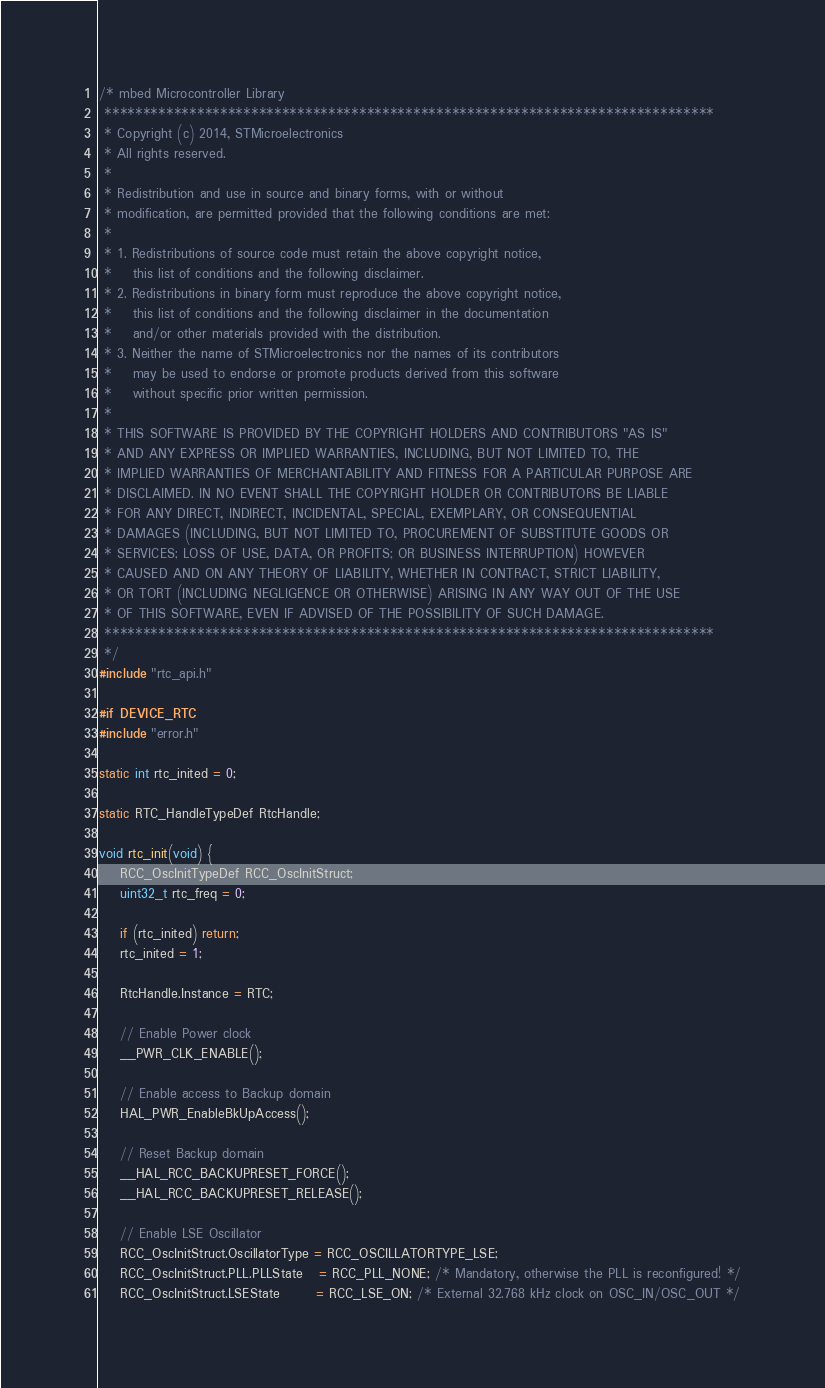<code> <loc_0><loc_0><loc_500><loc_500><_C_>/* mbed Microcontroller Library
 *******************************************************************************
 * Copyright (c) 2014, STMicroelectronics
 * All rights reserved.
 *
 * Redistribution and use in source and binary forms, with or without
 * modification, are permitted provided that the following conditions are met:
 *
 * 1. Redistributions of source code must retain the above copyright notice,
 *    this list of conditions and the following disclaimer.
 * 2. Redistributions in binary form must reproduce the above copyright notice,
 *    this list of conditions and the following disclaimer in the documentation
 *    and/or other materials provided with the distribution.
 * 3. Neither the name of STMicroelectronics nor the names of its contributors
 *    may be used to endorse or promote products derived from this software
 *    without specific prior written permission.
 *
 * THIS SOFTWARE IS PROVIDED BY THE COPYRIGHT HOLDERS AND CONTRIBUTORS "AS IS"
 * AND ANY EXPRESS OR IMPLIED WARRANTIES, INCLUDING, BUT NOT LIMITED TO, THE
 * IMPLIED WARRANTIES OF MERCHANTABILITY AND FITNESS FOR A PARTICULAR PURPOSE ARE
 * DISCLAIMED. IN NO EVENT SHALL THE COPYRIGHT HOLDER OR CONTRIBUTORS BE LIABLE
 * FOR ANY DIRECT, INDIRECT, INCIDENTAL, SPECIAL, EXEMPLARY, OR CONSEQUENTIAL
 * DAMAGES (INCLUDING, BUT NOT LIMITED TO, PROCUREMENT OF SUBSTITUTE GOODS OR
 * SERVICES; LOSS OF USE, DATA, OR PROFITS; OR BUSINESS INTERRUPTION) HOWEVER
 * CAUSED AND ON ANY THEORY OF LIABILITY, WHETHER IN CONTRACT, STRICT LIABILITY,
 * OR TORT (INCLUDING NEGLIGENCE OR OTHERWISE) ARISING IN ANY WAY OUT OF THE USE
 * OF THIS SOFTWARE, EVEN IF ADVISED OF THE POSSIBILITY OF SUCH DAMAGE.
 *******************************************************************************
 */
#include "rtc_api.h"

#if DEVICE_RTC
#include "error.h"

static int rtc_inited = 0;

static RTC_HandleTypeDef RtcHandle;

void rtc_init(void) {
    RCC_OscInitTypeDef RCC_OscInitStruct;
    uint32_t rtc_freq = 0;

    if (rtc_inited) return;
    rtc_inited = 1;

    RtcHandle.Instance = RTC;

    // Enable Power clock
    __PWR_CLK_ENABLE();

    // Enable access to Backup domain
    HAL_PWR_EnableBkUpAccess();

    // Reset Backup domain
    __HAL_RCC_BACKUPRESET_FORCE(); 
    __HAL_RCC_BACKUPRESET_RELEASE();
  
    // Enable LSE Oscillator
    RCC_OscInitStruct.OscillatorType = RCC_OSCILLATORTYPE_LSE;
    RCC_OscInitStruct.PLL.PLLState   = RCC_PLL_NONE; /* Mandatory, otherwise the PLL is reconfigured! */
    RCC_OscInitStruct.LSEState       = RCC_LSE_ON; /* External 32.768 kHz clock on OSC_IN/OSC_OUT */</code> 